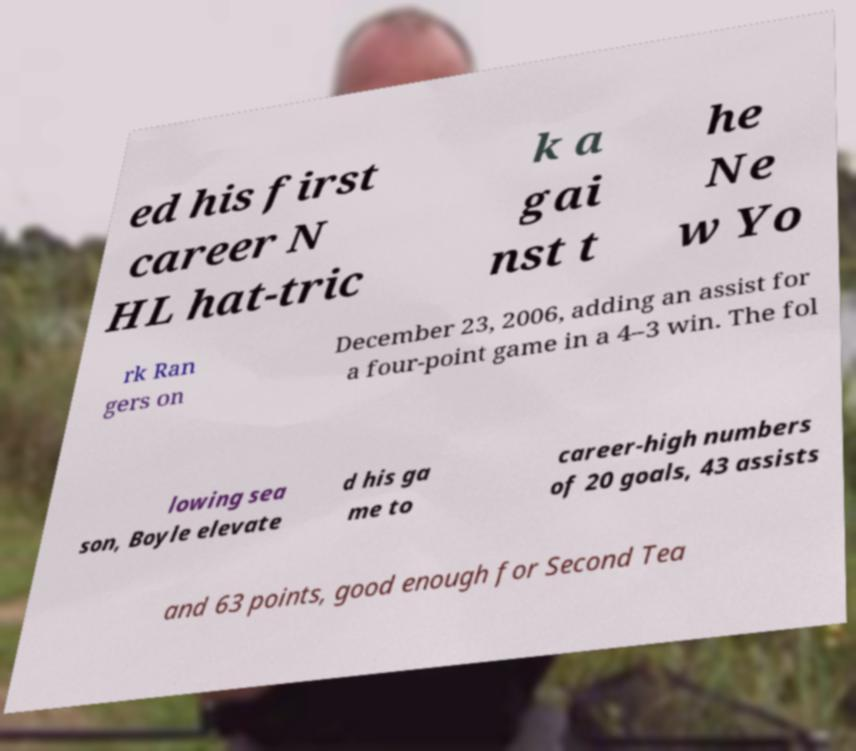For documentation purposes, I need the text within this image transcribed. Could you provide that? ed his first career N HL hat-tric k a gai nst t he Ne w Yo rk Ran gers on December 23, 2006, adding an assist for a four-point game in a 4–3 win. The fol lowing sea son, Boyle elevate d his ga me to career-high numbers of 20 goals, 43 assists and 63 points, good enough for Second Tea 